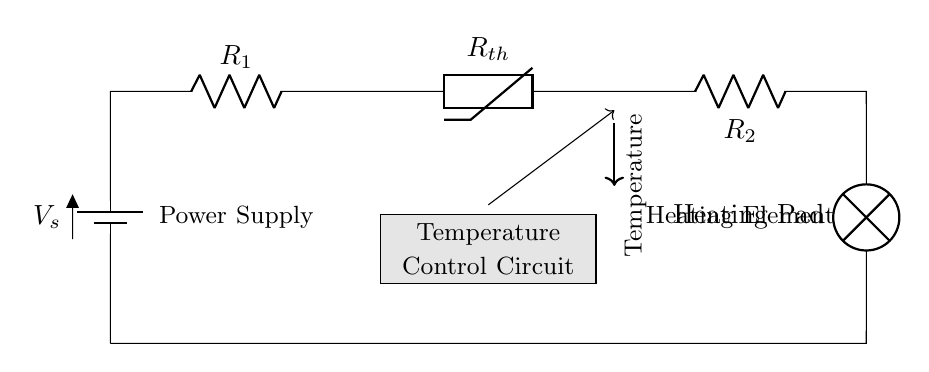What is the type of circuit depicted? The circuit is a series circuit, characterized by the components being connected in a sequence. This means that current flows through each component one after the other.
Answer: Series What does the thermistor in the circuit do? The thermistor is a temperature-sensitive resistor that changes its resistance based on temperature. Its resistance decreases as temperature increases, which helps in controlling the heating pad's power based on the set temperature.
Answer: Temperature control How many resistors are present in the circuit? There are two resistors, labeled R1 and R2, in addition to the thermistor which also acts as a resistor. Thus the total number of resistive components is three.
Answer: Three What is the role of the heating pad in the circuit? The heating pad functions as the heating element that converts electrical energy into heat, providing warmth. The circuit delivers the necessary current to this pad based on the temperature readings.
Answer: Heating element How does the voltage supply connect to the circuit? The voltage supply connects to the circuit at one side, providing the power needed for all components to operate. It is positioned at the top left as shown in the diagram.
Answer: Power supply 